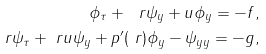Convert formula to latex. <formula><loc_0><loc_0><loc_500><loc_500>\phi _ { \tau } + \ r \psi _ { y } + u \phi _ { y } = - f , \\ \ r \psi _ { \tau } + \ r u \psi _ { y } + p ^ { \prime } ( \ r ) \phi _ { y } - \psi _ { y y } = - g ,</formula> 